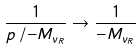<formula> <loc_0><loc_0><loc_500><loc_500>\frac { 1 } { p \, / - M _ { \nu _ { R } } } \rightarrow \frac { 1 } { - M _ { \nu _ { R } } }</formula> 